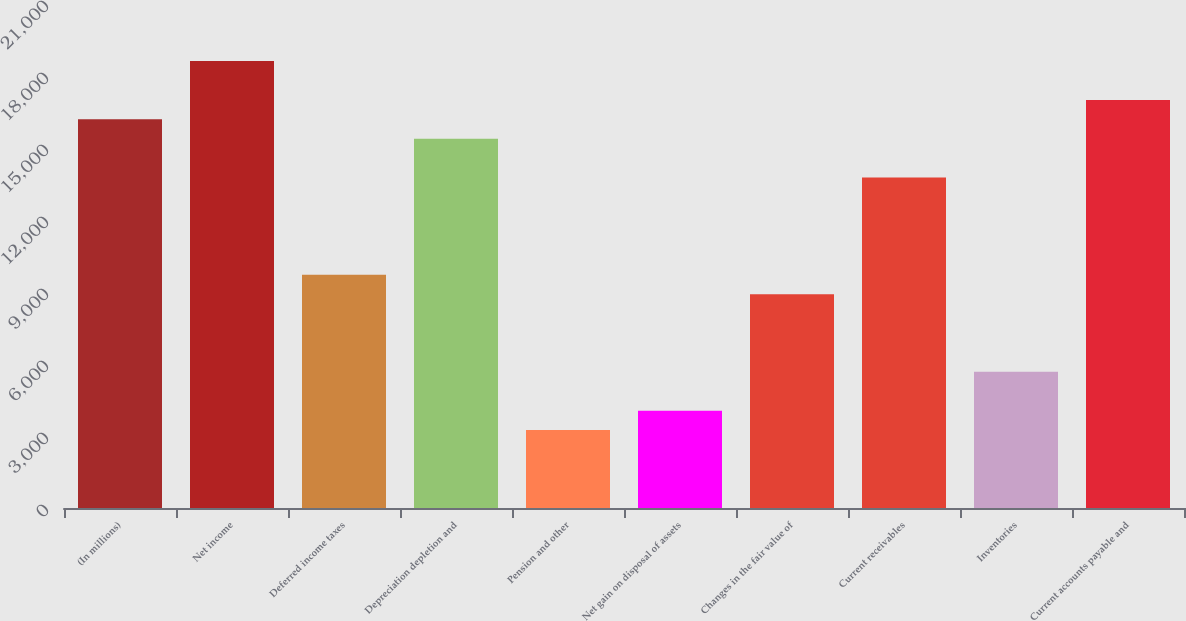<chart> <loc_0><loc_0><loc_500><loc_500><bar_chart><fcel>(In millions)<fcel>Net income<fcel>Deferred income taxes<fcel>Depreciation depletion and<fcel>Pension and other<fcel>Net gain on disposal of assets<fcel>Changes in the fair value of<fcel>Current receivables<fcel>Inventories<fcel>Current accounts payable and<nl><fcel>16195<fcel>18622.9<fcel>9720.6<fcel>15385.7<fcel>3246.2<fcel>4055.5<fcel>8911.3<fcel>13767.1<fcel>5674.1<fcel>17004.3<nl></chart> 